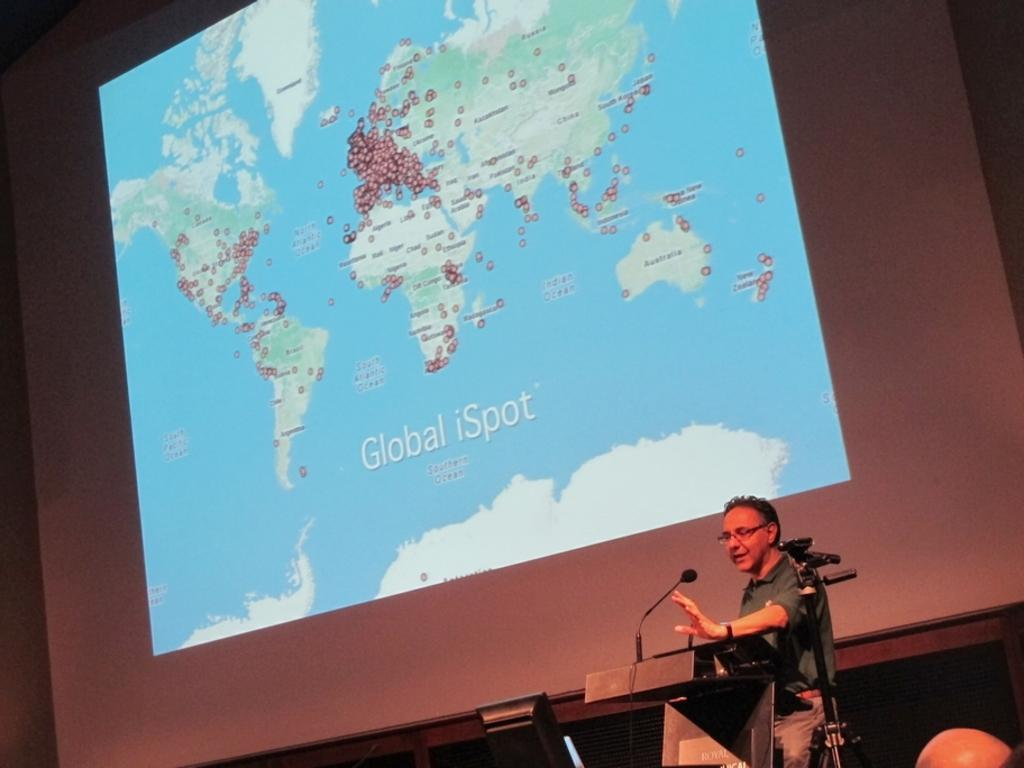What is displayed in the background of the image? There is a screen with information in the background of the image. Who is present in the image? There is a man in the image. What object is used for amplifying sound in the image? There is a microphone in the image. What is the man standing behind in the image? There is a podium in the image. Can you describe any other objects present in the image? There are other objects present in the image, but their specific details are not mentioned in the provided facts. How many cats can be seen playing with the moon in the image? There are no cats or moons present in the image. What type of cake is being served in the image? There is no cake present in the image. 